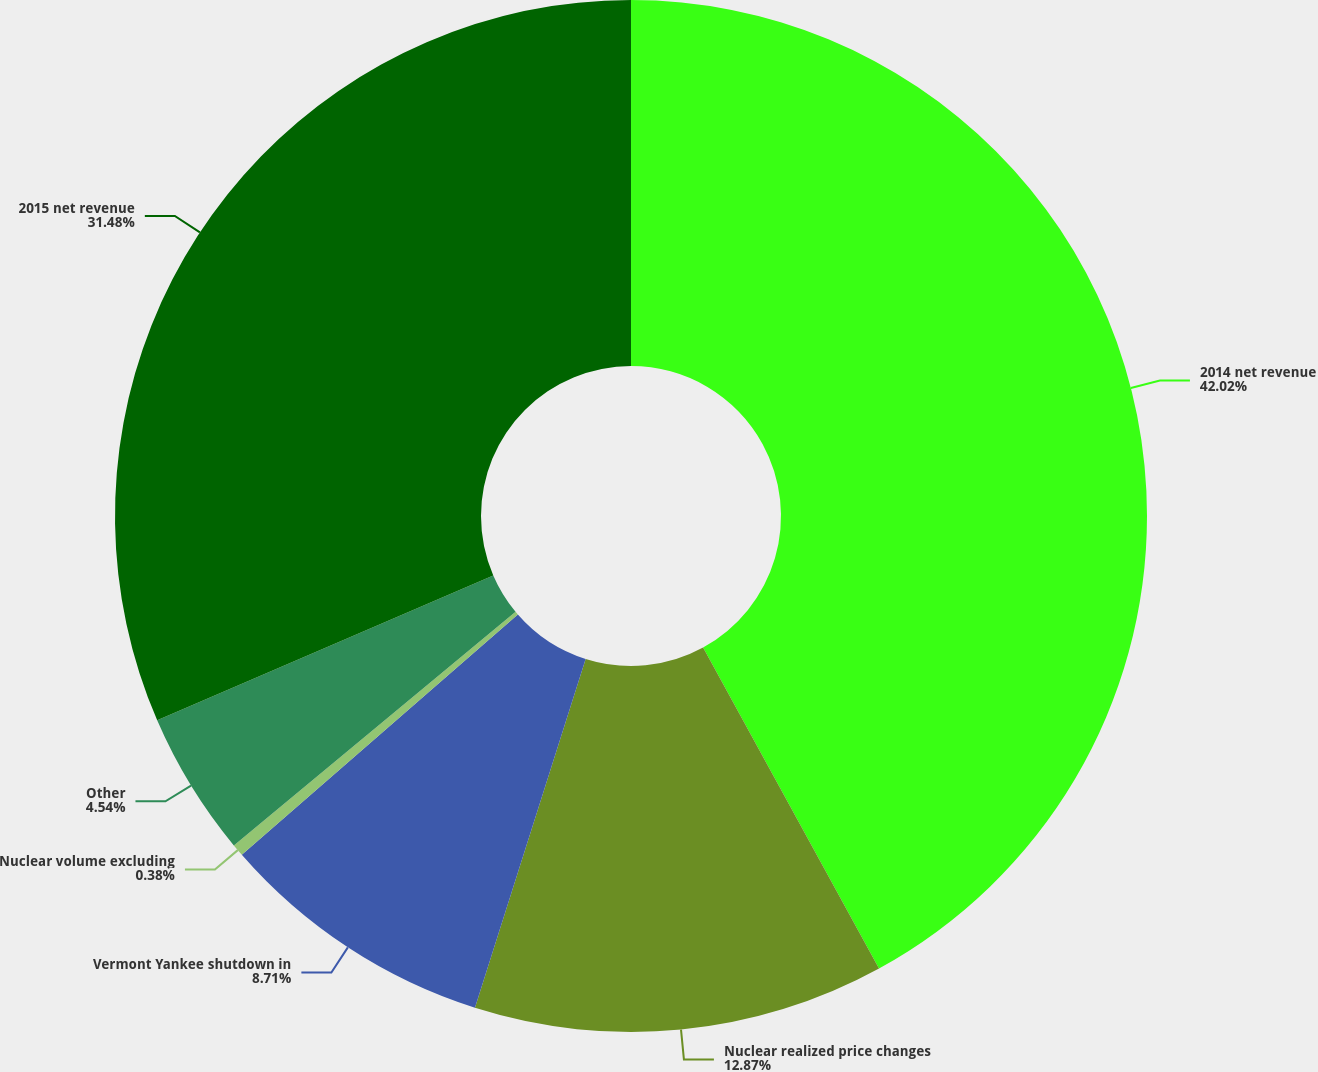Convert chart. <chart><loc_0><loc_0><loc_500><loc_500><pie_chart><fcel>2014 net revenue<fcel>Nuclear realized price changes<fcel>Vermont Yankee shutdown in<fcel>Nuclear volume excluding<fcel>Other<fcel>2015 net revenue<nl><fcel>42.02%<fcel>12.87%<fcel>8.71%<fcel>0.38%<fcel>4.54%<fcel>31.48%<nl></chart> 